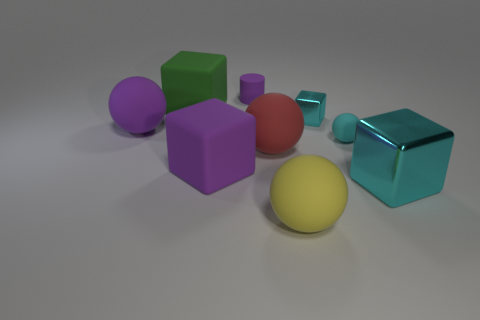If these objects were part of a toy set, which age group would they be suitable for? These objects could be part of an educational toy set aimed at young children, perhaps aged three to six, designed to teach shapes, colors, and material textures in a playful manner. 